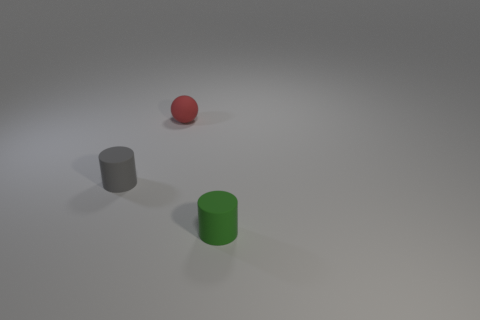Is there a tiny gray cylinder that is in front of the gray thing that is in front of the red ball?
Provide a succinct answer. No. There is a rubber cylinder left of the small cylinder that is right of the gray matte object; is there a matte cylinder behind it?
Offer a terse response. No. There is a matte object behind the gray thing; does it have the same shape as the small matte thing on the left side of the tiny red matte object?
Your response must be concise. No. There is another tiny cylinder that is made of the same material as the tiny gray cylinder; what is its color?
Offer a very short reply. Green. Are there fewer gray cylinders to the right of the tiny gray cylinder than cylinders?
Provide a short and direct response. Yes. What size is the cylinder left of the object in front of the tiny matte object to the left of the small rubber ball?
Your response must be concise. Small. Is the material of the small cylinder right of the tiny rubber ball the same as the red object?
Your answer should be very brief. Yes. Is there any other thing that is the same shape as the small gray rubber object?
Your response must be concise. Yes. How many things are either tiny red matte things or red rubber cylinders?
Ensure brevity in your answer.  1. What is the size of the green rubber thing that is the same shape as the tiny gray object?
Provide a short and direct response. Small. 